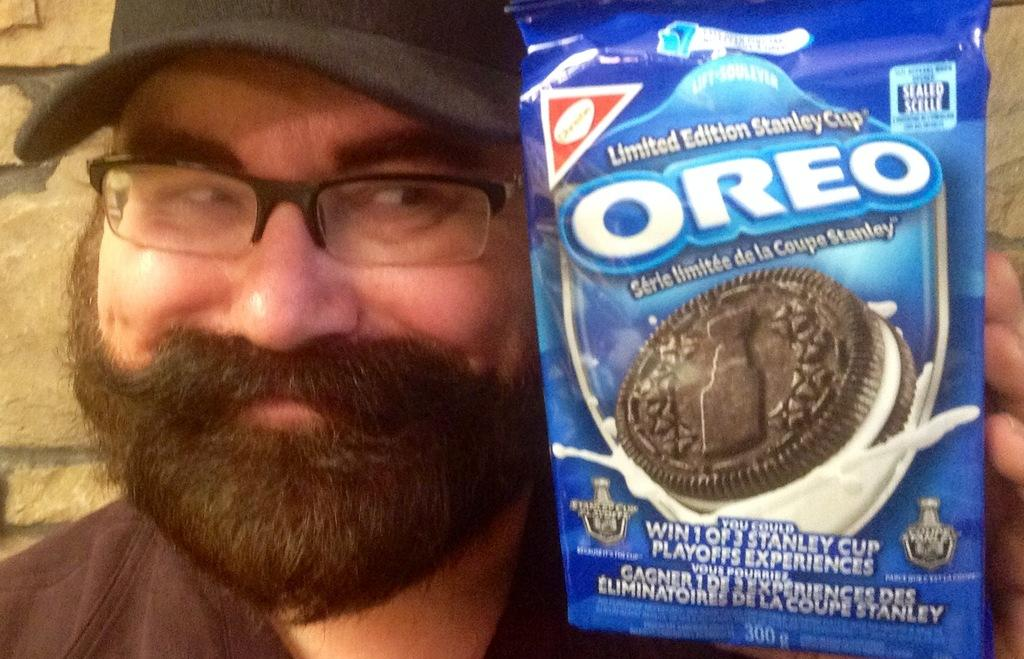Who is present in the image? There is a person in the image. What is the person wearing on their head? The person is wearing a cap. What is the person holding in their hand? The person is holding a packet in their hand. What can be seen in the background of the image? There is a wall in the background of the image. Is the person playing a guitar with their friend and dog in the image? There is no guitar, friend, or dog present in the image; it only features a person wearing a cap and holding a packet, with a wall in the background. 